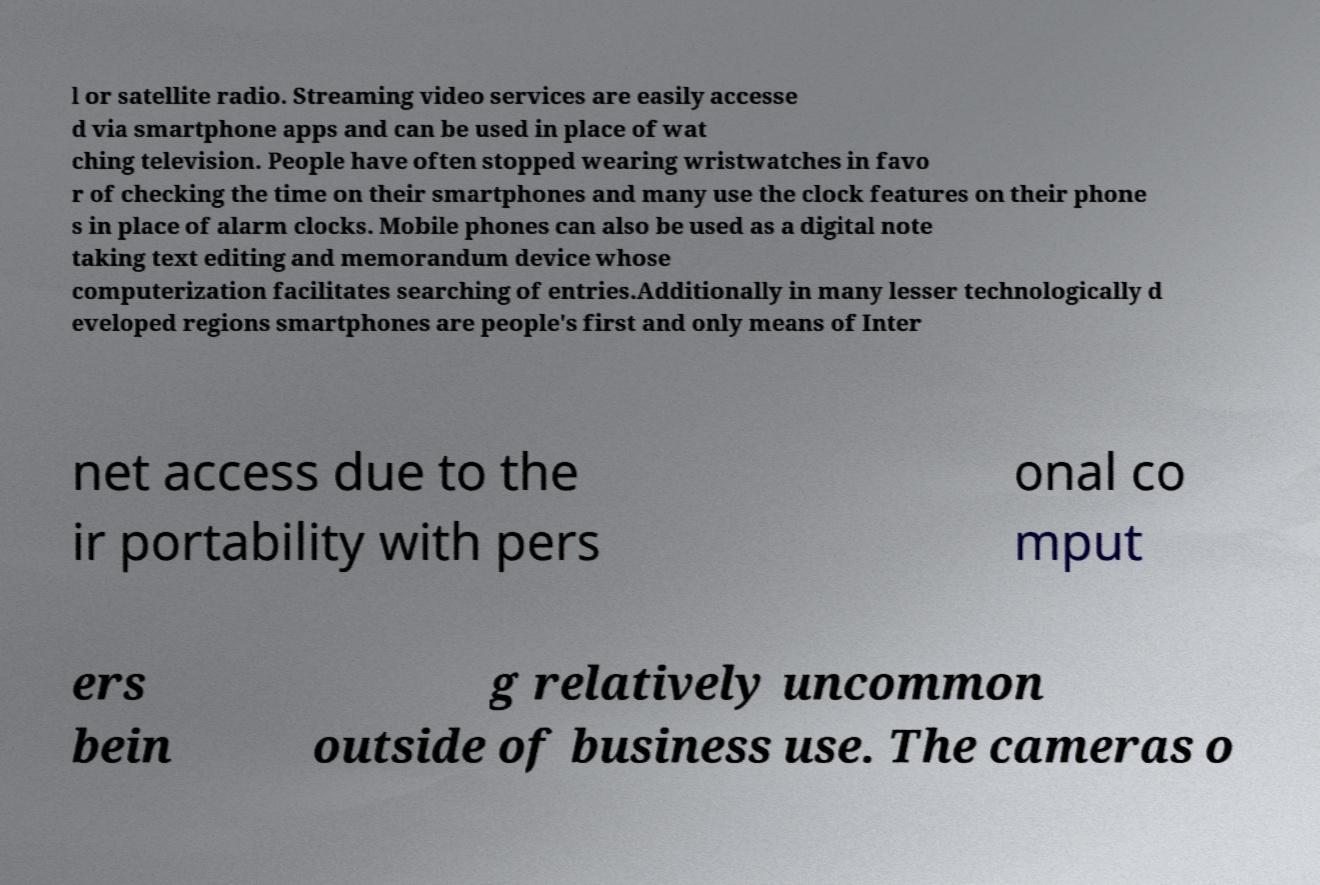Please identify and transcribe the text found in this image. l or satellite radio. Streaming video services are easily accesse d via smartphone apps and can be used in place of wat ching television. People have often stopped wearing wristwatches in favo r of checking the time on their smartphones and many use the clock features on their phone s in place of alarm clocks. Mobile phones can also be used as a digital note taking text editing and memorandum device whose computerization facilitates searching of entries.Additionally in many lesser technologically d eveloped regions smartphones are people's first and only means of Inter net access due to the ir portability with pers onal co mput ers bein g relatively uncommon outside of business use. The cameras o 